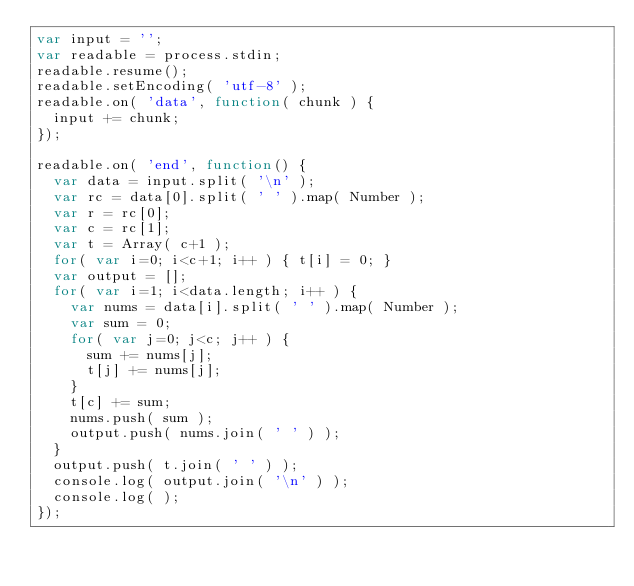Convert code to text. <code><loc_0><loc_0><loc_500><loc_500><_JavaScript_>var input = '';
var readable = process.stdin;
readable.resume();
readable.setEncoding( 'utf-8' );
readable.on( 'data', function( chunk ) {
  input += chunk;
});

readable.on( 'end', function() {
  var data = input.split( '\n' );
  var rc = data[0].split( ' ' ).map( Number );
  var r = rc[0];
  var c = rc[1]; 
  var t = Array( c+1 );
  for( var i=0; i<c+1; i++ ) { t[i] = 0; }
  var output = [];
  for( var i=1; i<data.length; i++ ) {
    var nums = data[i].split( ' ' ).map( Number );
    var sum = 0;
    for( var j=0; j<c; j++ ) {
      sum += nums[j];
      t[j] += nums[j];
    }
    t[c] += sum;
    nums.push( sum );
    output.push( nums.join( ' ' ) );
  }
  output.push( t.join( ' ' ) );
  console.log( output.join( '\n' ) );
  console.log( );
});
 </code> 